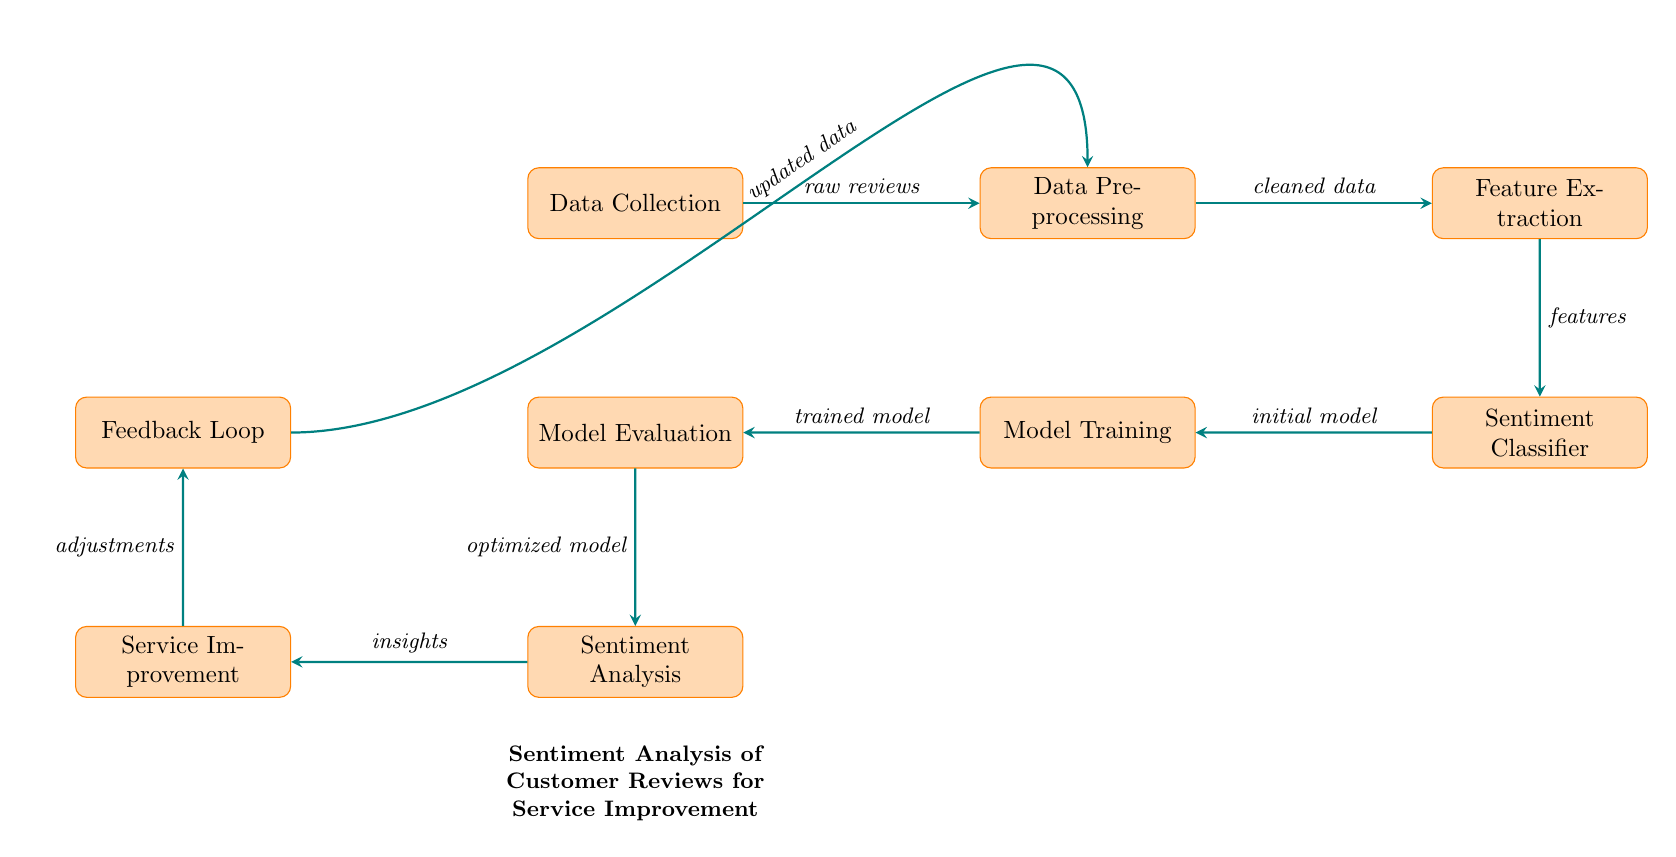What is the first node in the diagram? The first node is labeled "Data Collection," indicating the initial step of gathering customer reviews.
Answer: Data Collection How many total nodes are present in the diagram? By counting each labeled process, there are eight distinct nodes connected within the diagram.
Answer: Eight What type of data flows from 'Data Collection' to 'Data Preprocessing'? The diagram indicates that 'raw reviews' flow from the 'Data Collection' node to 'Data Preprocessing' node.
Answer: Raw reviews Which node receives the output from 'Model Training'? The next node that receives output after 'Model Training' is 'Model Evaluation,' as indicated by the directed flow of the diagram.
Answer: Model Evaluation What does the 'Sentiment Classifier' output? The output from the 'Sentiment Classifier' is labeled 'initial model,' showing the result of classification based on the extracted features.
Answer: Initial model What is the final process noted before returning to 'Data Preprocessing'? The process is labeled 'Feedback Loop,' which signifies adjustments made before updating the data for retraining.
Answer: Feedback Loop Which process is directly linked to 'Service Improvement'? The 'Sentiment Analysis' node provides insights to the 'Service Improvement' process based on the sentiment results obtained.
Answer: Sentiment Analysis What type of insights are derived from 'Sentiment Analysis'? The 'insights' generated from the 'Sentiment Analysis' help in guiding the 'Service Improvement' process.
Answer: Insights What is being optimized in 'Model Evaluation'? The 'Model Evaluation' process works on optimizing the model to improve its performance in sentiment classification.
Answer: Optimized model 